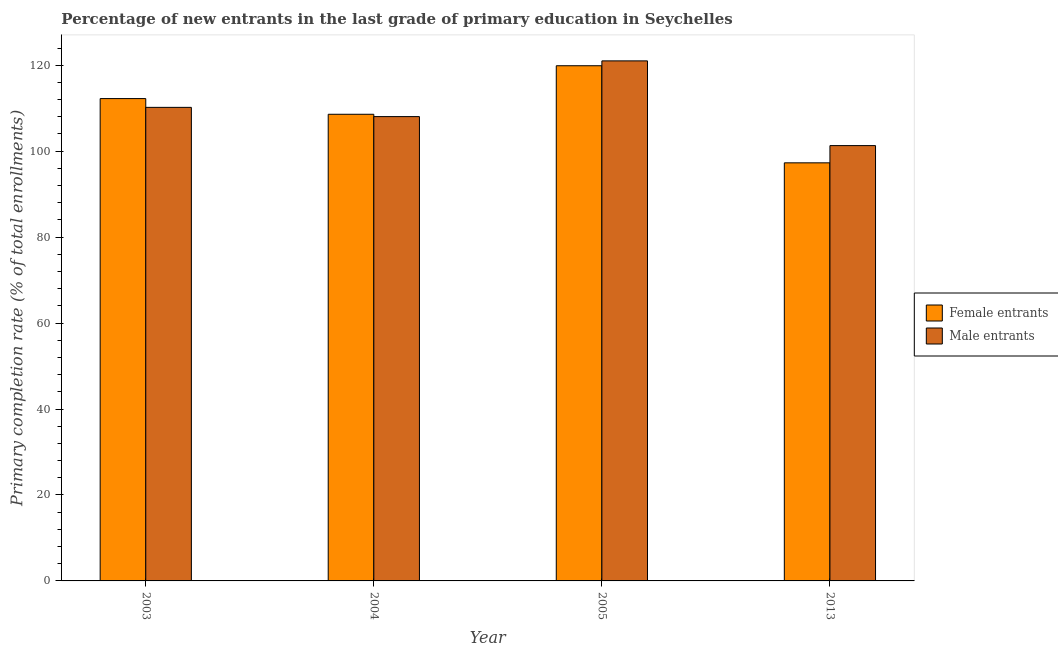How many bars are there on the 3rd tick from the left?
Make the answer very short. 2. In how many cases, is the number of bars for a given year not equal to the number of legend labels?
Provide a short and direct response. 0. What is the primary completion rate of female entrants in 2013?
Ensure brevity in your answer.  97.29. Across all years, what is the maximum primary completion rate of female entrants?
Your answer should be compact. 119.88. Across all years, what is the minimum primary completion rate of male entrants?
Provide a succinct answer. 101.3. In which year was the primary completion rate of male entrants minimum?
Offer a very short reply. 2013. What is the total primary completion rate of female entrants in the graph?
Give a very brief answer. 438. What is the difference between the primary completion rate of male entrants in 2003 and that in 2005?
Ensure brevity in your answer.  -10.82. What is the difference between the primary completion rate of female entrants in 2005 and the primary completion rate of male entrants in 2013?
Keep it short and to the point. 22.59. What is the average primary completion rate of female entrants per year?
Offer a very short reply. 109.5. In the year 2005, what is the difference between the primary completion rate of female entrants and primary completion rate of male entrants?
Your answer should be very brief. 0. In how many years, is the primary completion rate of male entrants greater than 100 %?
Offer a very short reply. 4. What is the ratio of the primary completion rate of male entrants in 2003 to that in 2005?
Provide a short and direct response. 0.91. What is the difference between the highest and the second highest primary completion rate of female entrants?
Provide a succinct answer. 7.64. What is the difference between the highest and the lowest primary completion rate of male entrants?
Make the answer very short. 19.72. In how many years, is the primary completion rate of female entrants greater than the average primary completion rate of female entrants taken over all years?
Your answer should be compact. 2. Is the sum of the primary completion rate of female entrants in 2003 and 2004 greater than the maximum primary completion rate of male entrants across all years?
Your answer should be very brief. Yes. What does the 1st bar from the left in 2004 represents?
Your response must be concise. Female entrants. What does the 2nd bar from the right in 2003 represents?
Ensure brevity in your answer.  Female entrants. How many years are there in the graph?
Make the answer very short. 4. What is the difference between two consecutive major ticks on the Y-axis?
Your answer should be very brief. 20. Are the values on the major ticks of Y-axis written in scientific E-notation?
Your answer should be compact. No. What is the title of the graph?
Your response must be concise. Percentage of new entrants in the last grade of primary education in Seychelles. Does "From World Bank" appear as one of the legend labels in the graph?
Make the answer very short. No. What is the label or title of the Y-axis?
Ensure brevity in your answer.  Primary completion rate (% of total enrollments). What is the Primary completion rate (% of total enrollments) in Female entrants in 2003?
Give a very brief answer. 112.24. What is the Primary completion rate (% of total enrollments) of Male entrants in 2003?
Offer a terse response. 110.2. What is the Primary completion rate (% of total enrollments) of Female entrants in 2004?
Give a very brief answer. 108.59. What is the Primary completion rate (% of total enrollments) of Male entrants in 2004?
Offer a terse response. 108.05. What is the Primary completion rate (% of total enrollments) of Female entrants in 2005?
Give a very brief answer. 119.88. What is the Primary completion rate (% of total enrollments) in Male entrants in 2005?
Give a very brief answer. 121.02. What is the Primary completion rate (% of total enrollments) in Female entrants in 2013?
Your answer should be compact. 97.29. What is the Primary completion rate (% of total enrollments) of Male entrants in 2013?
Your answer should be very brief. 101.3. Across all years, what is the maximum Primary completion rate (% of total enrollments) in Female entrants?
Your response must be concise. 119.88. Across all years, what is the maximum Primary completion rate (% of total enrollments) of Male entrants?
Provide a short and direct response. 121.02. Across all years, what is the minimum Primary completion rate (% of total enrollments) of Female entrants?
Keep it short and to the point. 97.29. Across all years, what is the minimum Primary completion rate (% of total enrollments) of Male entrants?
Ensure brevity in your answer.  101.3. What is the total Primary completion rate (% of total enrollments) in Female entrants in the graph?
Your answer should be very brief. 438. What is the total Primary completion rate (% of total enrollments) in Male entrants in the graph?
Your response must be concise. 440.56. What is the difference between the Primary completion rate (% of total enrollments) of Female entrants in 2003 and that in 2004?
Your answer should be very brief. 3.65. What is the difference between the Primary completion rate (% of total enrollments) in Male entrants in 2003 and that in 2004?
Offer a terse response. 2.15. What is the difference between the Primary completion rate (% of total enrollments) of Female entrants in 2003 and that in 2005?
Keep it short and to the point. -7.64. What is the difference between the Primary completion rate (% of total enrollments) of Male entrants in 2003 and that in 2005?
Provide a succinct answer. -10.82. What is the difference between the Primary completion rate (% of total enrollments) in Female entrants in 2003 and that in 2013?
Give a very brief answer. 14.95. What is the difference between the Primary completion rate (% of total enrollments) in Male entrants in 2003 and that in 2013?
Ensure brevity in your answer.  8.9. What is the difference between the Primary completion rate (% of total enrollments) of Female entrants in 2004 and that in 2005?
Give a very brief answer. -11.29. What is the difference between the Primary completion rate (% of total enrollments) in Male entrants in 2004 and that in 2005?
Provide a short and direct response. -12.97. What is the difference between the Primary completion rate (% of total enrollments) of Female entrants in 2004 and that in 2013?
Keep it short and to the point. 11.3. What is the difference between the Primary completion rate (% of total enrollments) of Male entrants in 2004 and that in 2013?
Offer a very short reply. 6.75. What is the difference between the Primary completion rate (% of total enrollments) in Female entrants in 2005 and that in 2013?
Your answer should be very brief. 22.59. What is the difference between the Primary completion rate (% of total enrollments) in Male entrants in 2005 and that in 2013?
Offer a very short reply. 19.72. What is the difference between the Primary completion rate (% of total enrollments) of Female entrants in 2003 and the Primary completion rate (% of total enrollments) of Male entrants in 2004?
Keep it short and to the point. 4.19. What is the difference between the Primary completion rate (% of total enrollments) of Female entrants in 2003 and the Primary completion rate (% of total enrollments) of Male entrants in 2005?
Your answer should be compact. -8.78. What is the difference between the Primary completion rate (% of total enrollments) in Female entrants in 2003 and the Primary completion rate (% of total enrollments) in Male entrants in 2013?
Offer a terse response. 10.94. What is the difference between the Primary completion rate (% of total enrollments) of Female entrants in 2004 and the Primary completion rate (% of total enrollments) of Male entrants in 2005?
Keep it short and to the point. -12.42. What is the difference between the Primary completion rate (% of total enrollments) of Female entrants in 2004 and the Primary completion rate (% of total enrollments) of Male entrants in 2013?
Your response must be concise. 7.29. What is the difference between the Primary completion rate (% of total enrollments) in Female entrants in 2005 and the Primary completion rate (% of total enrollments) in Male entrants in 2013?
Keep it short and to the point. 18.59. What is the average Primary completion rate (% of total enrollments) of Female entrants per year?
Provide a short and direct response. 109.5. What is the average Primary completion rate (% of total enrollments) of Male entrants per year?
Give a very brief answer. 110.14. In the year 2003, what is the difference between the Primary completion rate (% of total enrollments) in Female entrants and Primary completion rate (% of total enrollments) in Male entrants?
Provide a succinct answer. 2.04. In the year 2004, what is the difference between the Primary completion rate (% of total enrollments) of Female entrants and Primary completion rate (% of total enrollments) of Male entrants?
Provide a short and direct response. 0.54. In the year 2005, what is the difference between the Primary completion rate (% of total enrollments) of Female entrants and Primary completion rate (% of total enrollments) of Male entrants?
Ensure brevity in your answer.  -1.13. In the year 2013, what is the difference between the Primary completion rate (% of total enrollments) in Female entrants and Primary completion rate (% of total enrollments) in Male entrants?
Make the answer very short. -4.01. What is the ratio of the Primary completion rate (% of total enrollments) of Female entrants in 2003 to that in 2004?
Provide a succinct answer. 1.03. What is the ratio of the Primary completion rate (% of total enrollments) in Male entrants in 2003 to that in 2004?
Your answer should be compact. 1.02. What is the ratio of the Primary completion rate (% of total enrollments) in Female entrants in 2003 to that in 2005?
Offer a very short reply. 0.94. What is the ratio of the Primary completion rate (% of total enrollments) in Male entrants in 2003 to that in 2005?
Your response must be concise. 0.91. What is the ratio of the Primary completion rate (% of total enrollments) in Female entrants in 2003 to that in 2013?
Provide a short and direct response. 1.15. What is the ratio of the Primary completion rate (% of total enrollments) of Male entrants in 2003 to that in 2013?
Provide a succinct answer. 1.09. What is the ratio of the Primary completion rate (% of total enrollments) of Female entrants in 2004 to that in 2005?
Provide a succinct answer. 0.91. What is the ratio of the Primary completion rate (% of total enrollments) of Male entrants in 2004 to that in 2005?
Offer a terse response. 0.89. What is the ratio of the Primary completion rate (% of total enrollments) in Female entrants in 2004 to that in 2013?
Provide a short and direct response. 1.12. What is the ratio of the Primary completion rate (% of total enrollments) of Male entrants in 2004 to that in 2013?
Provide a succinct answer. 1.07. What is the ratio of the Primary completion rate (% of total enrollments) of Female entrants in 2005 to that in 2013?
Ensure brevity in your answer.  1.23. What is the ratio of the Primary completion rate (% of total enrollments) of Male entrants in 2005 to that in 2013?
Offer a terse response. 1.19. What is the difference between the highest and the second highest Primary completion rate (% of total enrollments) in Female entrants?
Your response must be concise. 7.64. What is the difference between the highest and the second highest Primary completion rate (% of total enrollments) of Male entrants?
Your answer should be compact. 10.82. What is the difference between the highest and the lowest Primary completion rate (% of total enrollments) of Female entrants?
Make the answer very short. 22.59. What is the difference between the highest and the lowest Primary completion rate (% of total enrollments) of Male entrants?
Keep it short and to the point. 19.72. 